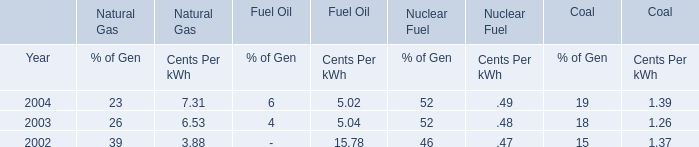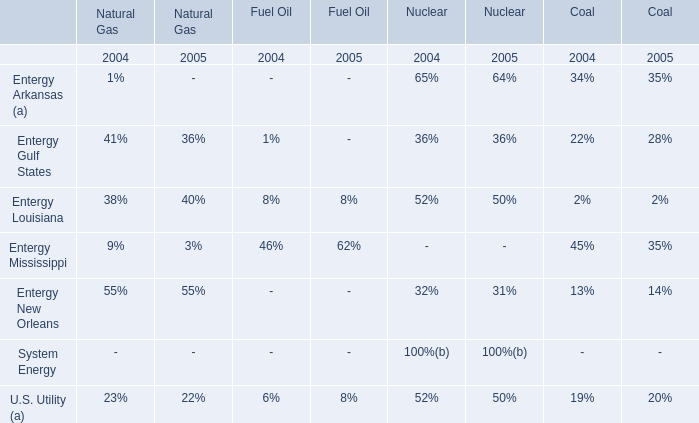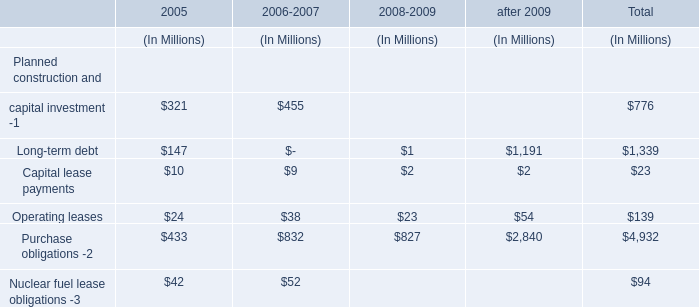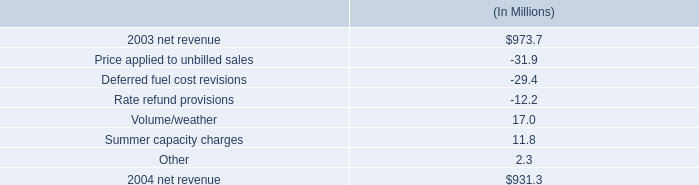what is the growth rate in net revenue in 2004 for entergy louisiana? 
Computations: ((931.3 - 973.7) / 973.7)
Answer: -0.04355. 